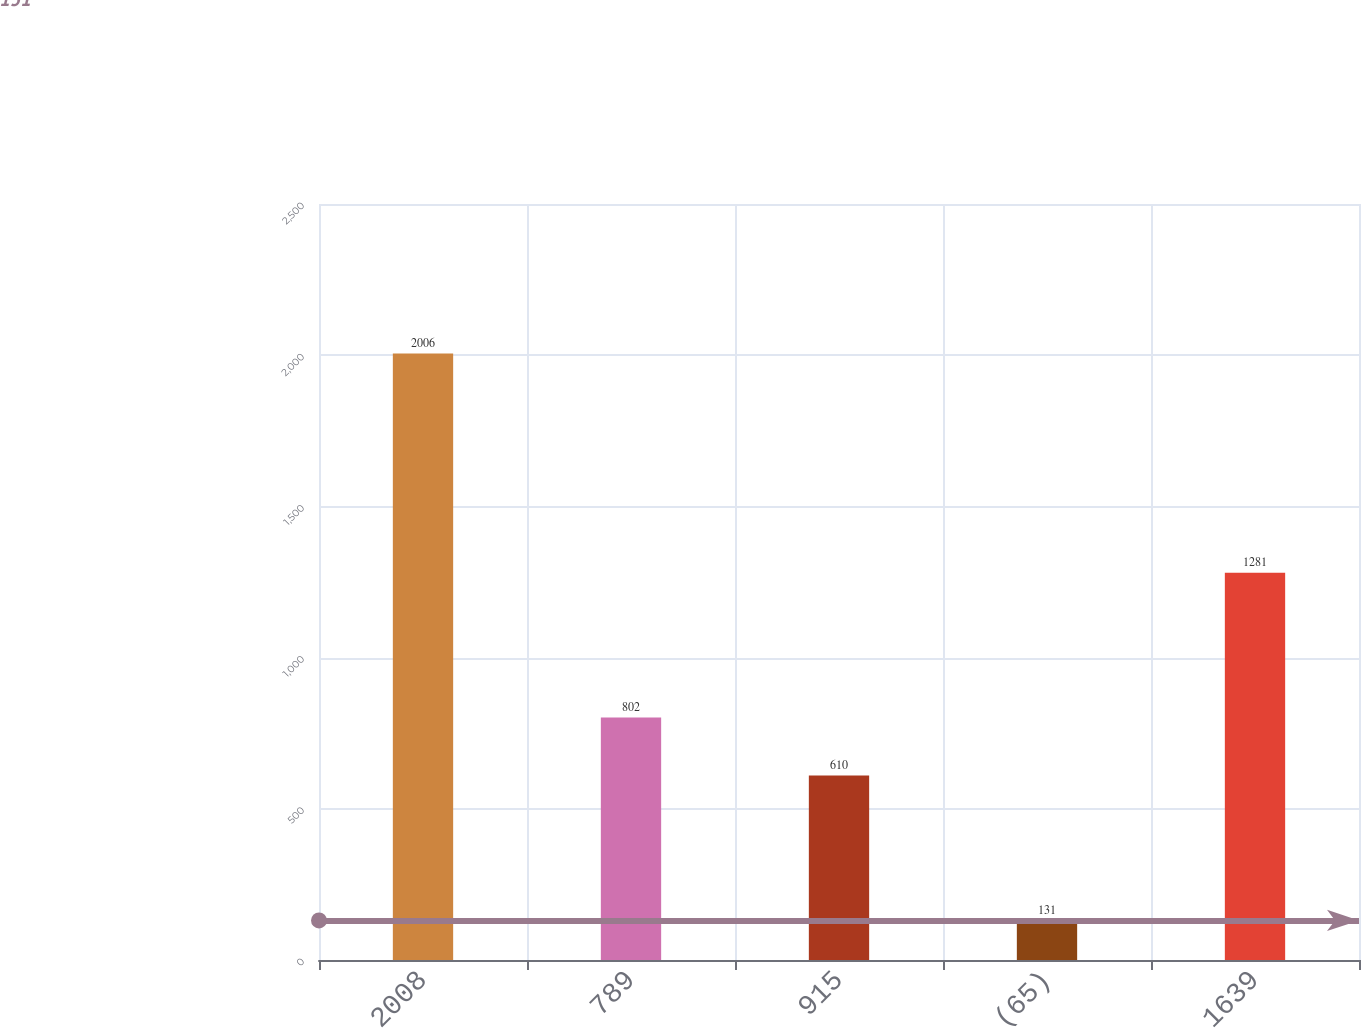Convert chart to OTSL. <chart><loc_0><loc_0><loc_500><loc_500><bar_chart><fcel>2008<fcel>789<fcel>915<fcel>(65)<fcel>1639<nl><fcel>2006<fcel>802<fcel>610<fcel>131<fcel>1281<nl></chart> 